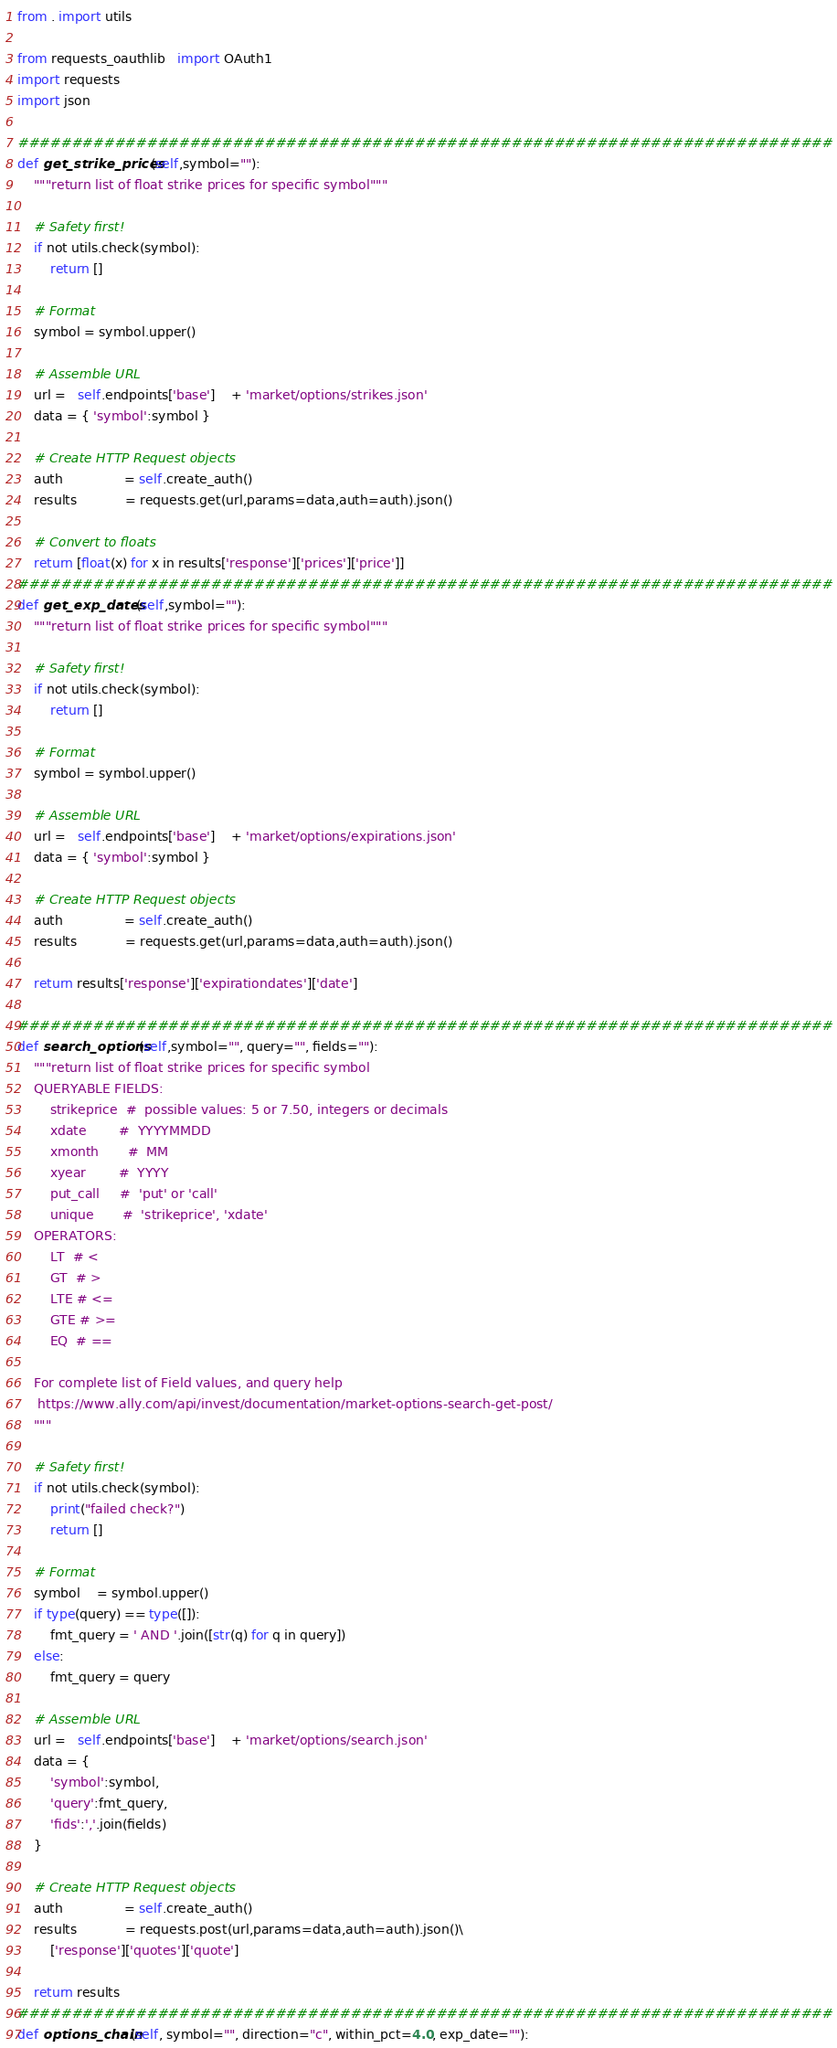<code> <loc_0><loc_0><loc_500><loc_500><_Python_>from . import utils

from requests_oauthlib   import OAuth1
import requests
import json

############################################################################
def get_strike_prices(self,symbol=""):
    """return list of float strike prices for specific symbol"""
    
    # Safety first!
    if not utils.check(symbol):
        return []
    
    # Format
    symbol = symbol.upper()
    
    # Assemble URL
    url =   self.endpoints['base']    + 'market/options/strikes.json'
    data = { 'symbol':symbol }
    
    # Create HTTP Request objects
    auth               = self.create_auth()
    results            = requests.get(url,params=data,auth=auth).json()
    
    # Convert to floats
    return [float(x) for x in results['response']['prices']['price']]
############################################################################
def get_exp_dates(self,symbol=""):
    """return list of float strike prices for specific symbol"""
    
    # Safety first!
    if not utils.check(symbol):
        return []
    
    # Format
    symbol = symbol.upper()
    
    # Assemble URL
    url =   self.endpoints['base']    + 'market/options/expirations.json'
    data = { 'symbol':symbol }
    
    # Create HTTP Request objects
    auth               = self.create_auth()
    results            = requests.get(url,params=data,auth=auth).json()
    
    return results['response']['expirationdates']['date']
    
############################################################################
def search_options(self,symbol="", query="", fields=""):
    """return list of float strike prices for specific symbol
    QUERYABLE FIELDS:
        strikeprice  #  possible values: 5 or 7.50, integers or decimals         
        xdate        #  YYYYMMDD
        xmonth       #  MM
        xyear        #  YYYY 
        put_call     #  'put' or 'call'  
        unique       #  'strikeprice', 'xdate'
    OPERATORS:
        LT  # <
        GT  # >
        LTE # <=
        GTE # >=
        EQ  # ==

    For complete list of Field values, and query help
     https://www.ally.com/api/invest/documentation/market-options-search-get-post/
    """
    
    # Safety first!
    if not utils.check(symbol):
        print("failed check?")
        return []
    
    # Format
    symbol    = symbol.upper()
    if type(query) == type([]):
        fmt_query = ' AND '.join([str(q) for q in query])
    else:
        fmt_query = query
    
    # Assemble URL
    url =   self.endpoints['base']    + 'market/options/search.json'
    data = {
        'symbol':symbol,
        'query':fmt_query,
        'fids':','.join(fields)
    }
    
    # Create HTTP Request objects
    auth               = self.create_auth()
    results            = requests.post(url,params=data,auth=auth).json()\
        ['response']['quotes']['quote']
    
    return results
############################################################################
def options_chain(self, symbol="", direction="c", within_pct=4.0, exp_date=""):</code> 